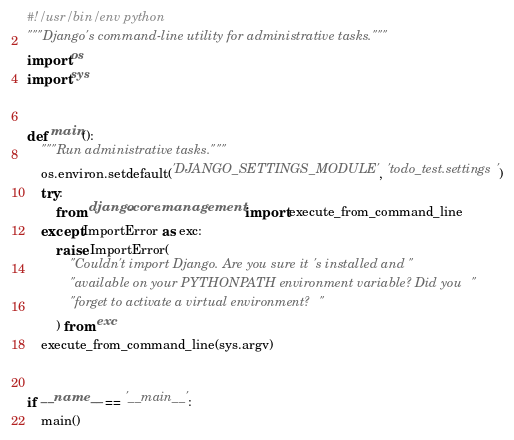Convert code to text. <code><loc_0><loc_0><loc_500><loc_500><_Python_>#!/usr/bin/env python
"""Django's command-line utility for administrative tasks."""
import os
import sys


def main():
    """Run administrative tasks."""
    os.environ.setdefault('DJANGO_SETTINGS_MODULE', 'todo_test.settings')
    try:
        from django.core.management import execute_from_command_line
    except ImportError as exc:
        raise ImportError(
            "Couldn't import Django. Are you sure it's installed and "
            "available on your PYTHONPATH environment variable? Did you "
            "forget to activate a virtual environment?"
        ) from exc
    execute_from_command_line(sys.argv)


if __name__ == '__main__':
    main()
</code> 